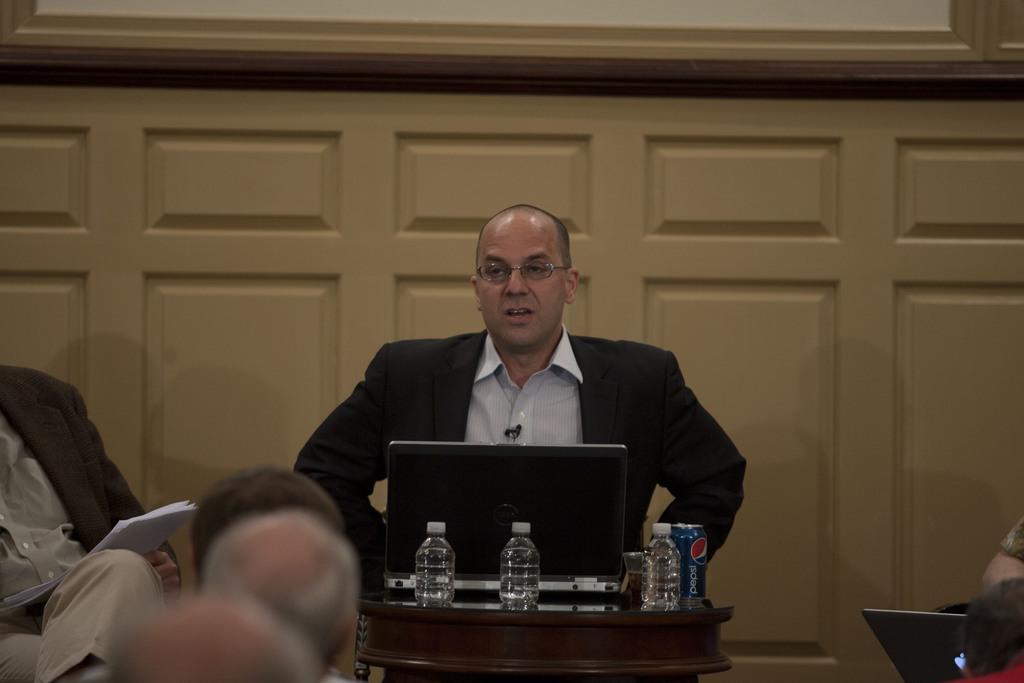In one or two sentences, can you explain what this image depicts? In this picture we can see a man wearing spectacles and a blazer. Near to him we can see a laptop, bottles and a tin. On the left side of the picture we can see another person. These are papers. On the right side of the picture we can see a laptop. Here we can see few other people. 